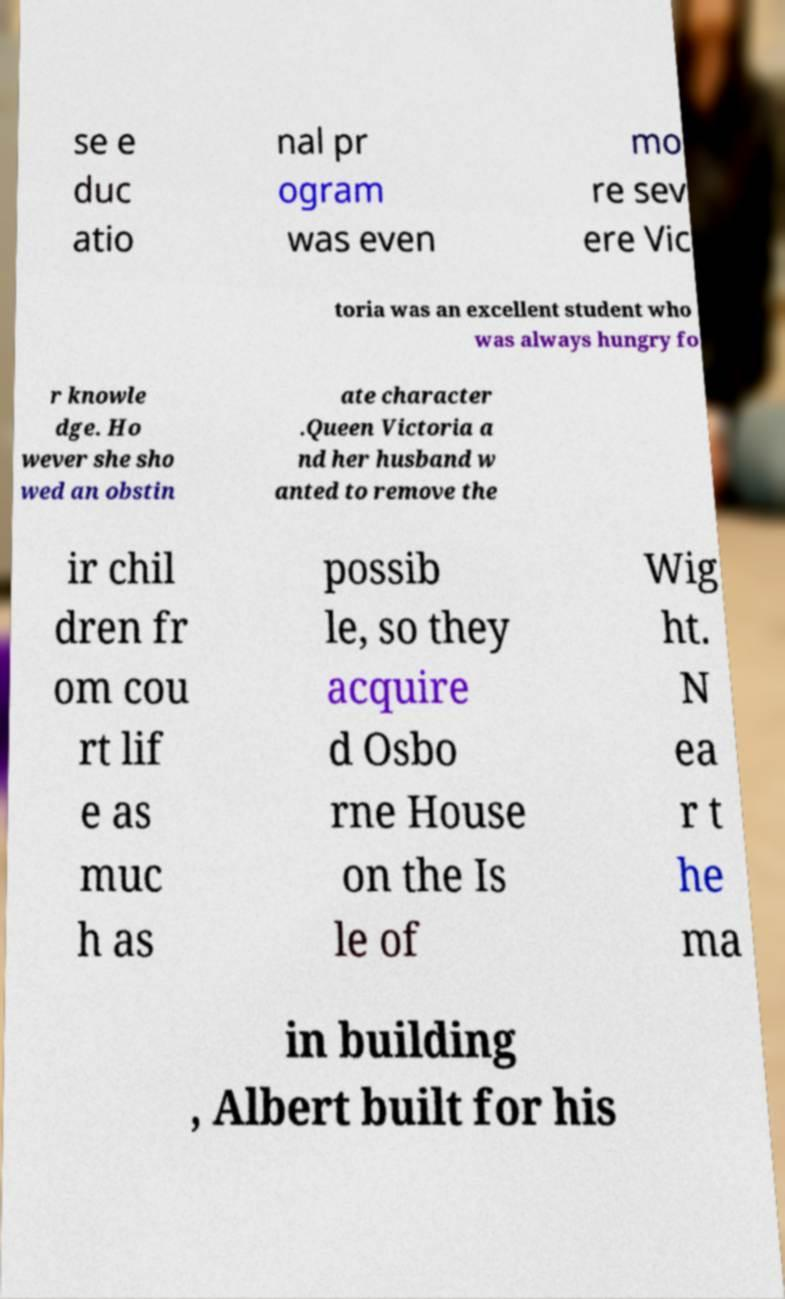For documentation purposes, I need the text within this image transcribed. Could you provide that? se e duc atio nal pr ogram was even mo re sev ere Vic toria was an excellent student who was always hungry fo r knowle dge. Ho wever she sho wed an obstin ate character .Queen Victoria a nd her husband w anted to remove the ir chil dren fr om cou rt lif e as muc h as possib le, so they acquire d Osbo rne House on the Is le of Wig ht. N ea r t he ma in building , Albert built for his 